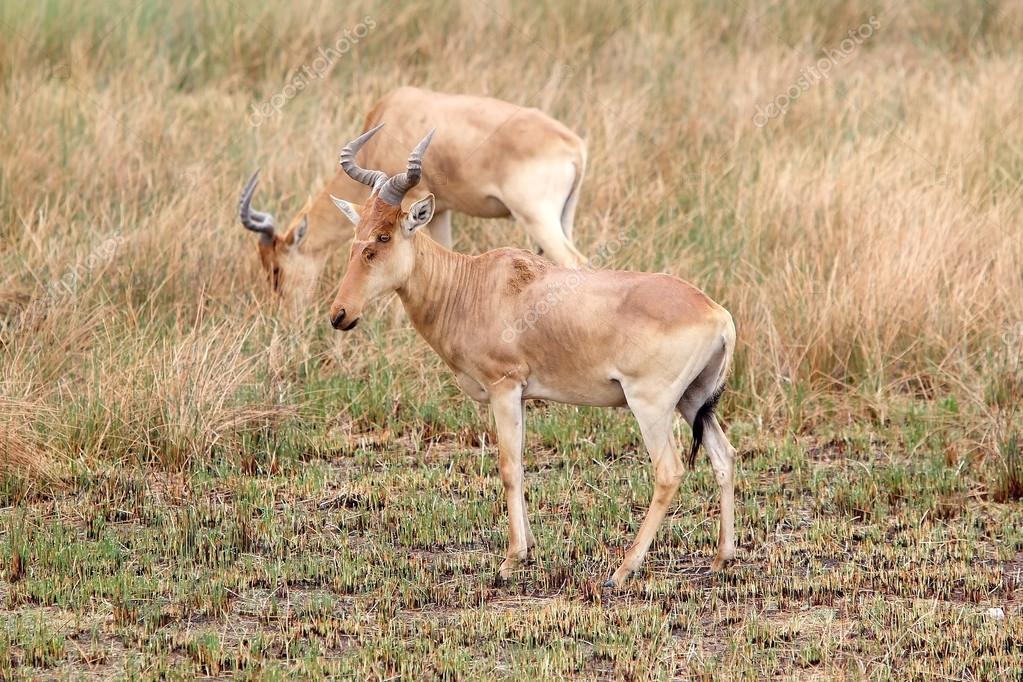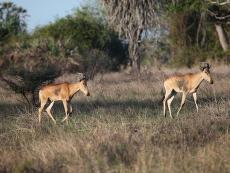The first image is the image on the left, the second image is the image on the right. Considering the images on both sides, is "Each image contains one horned animal, and the animals on the left and right have their bodies turned in the same general direction." valid? Answer yes or no. No. The first image is the image on the left, the second image is the image on the right. For the images shown, is this caption "All animals are oriented/facing the same direction." true? Answer yes or no. No. 